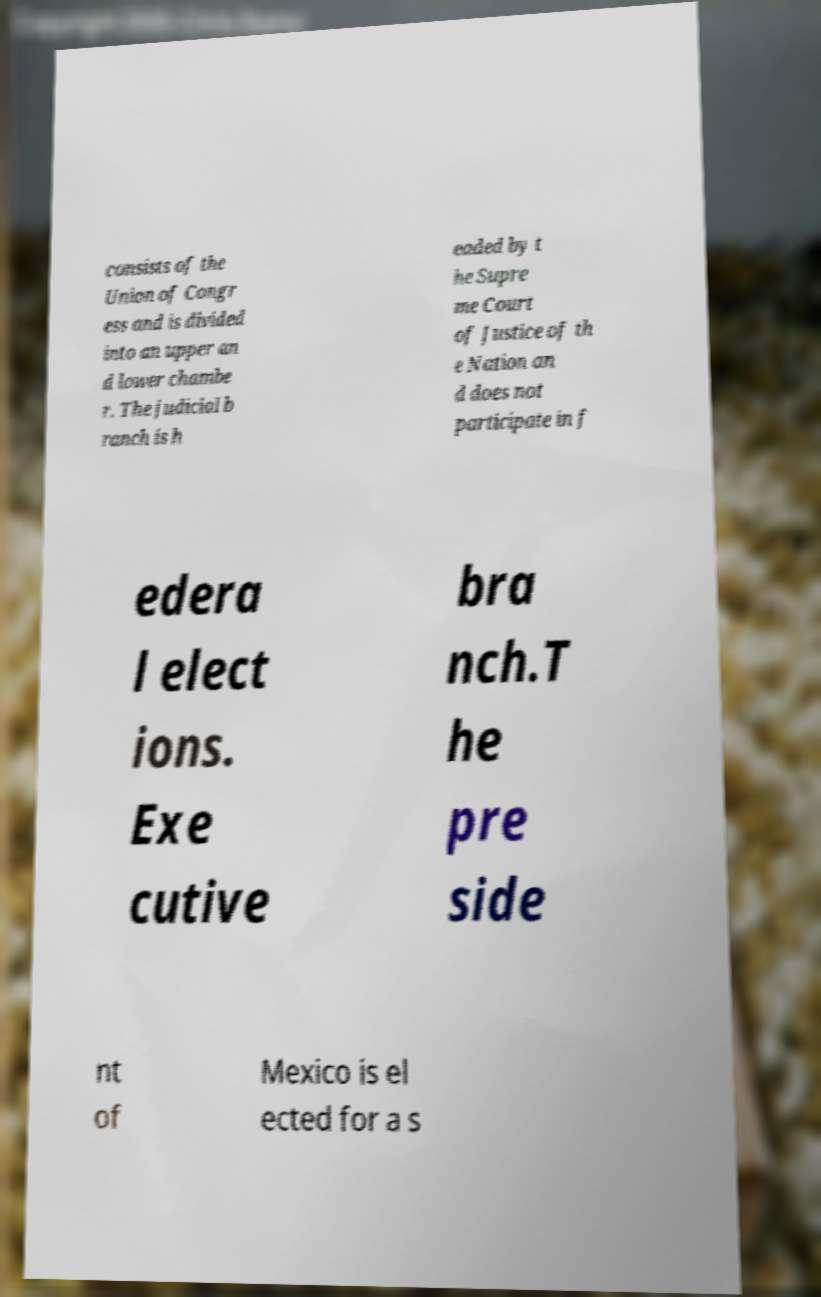What messages or text are displayed in this image? I need them in a readable, typed format. consists of the Union of Congr ess and is divided into an upper an d lower chambe r. The judicial b ranch is h eaded by t he Supre me Court of Justice of th e Nation an d does not participate in f edera l elect ions. Exe cutive bra nch.T he pre side nt of Mexico is el ected for a s 